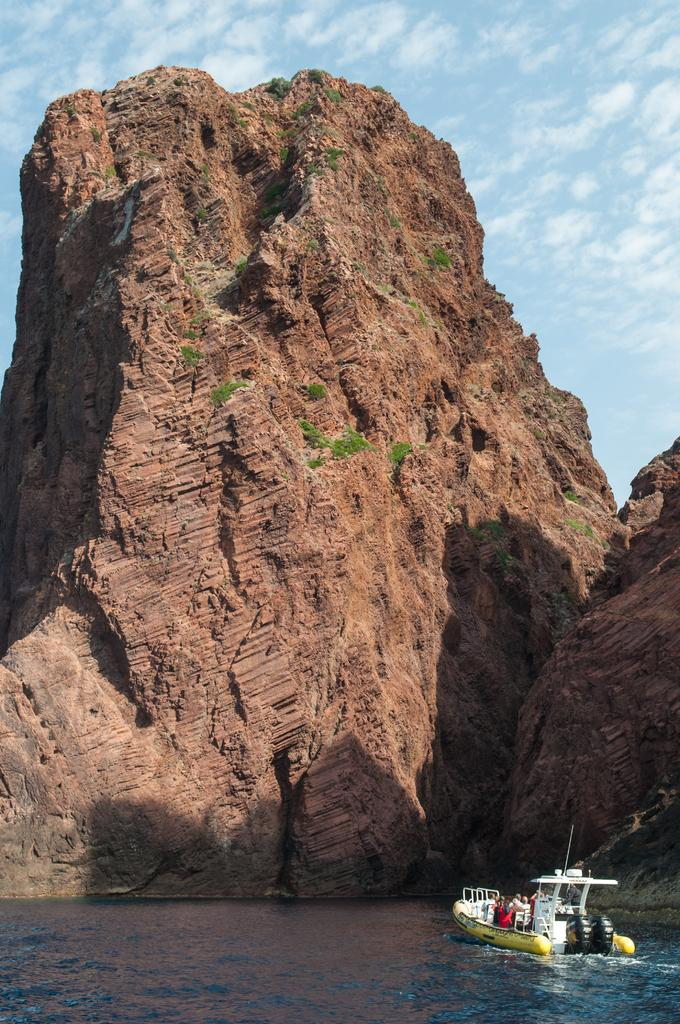What is located at the bottom of the image? There is a boat on the water at the bottom of the image. Who or what is inside the boat? There are people in the boat. What can be seen in the background of the image? There are hills in the background of the image. What is visible at the top of the image? The sky is visible at the top of the image. What is present in the sky? There are clouds in the sky. How many wrens can be seen flying in the image? There are no wrens present in the image. What is the fifth element in the image? The image only contains five elements mentioned in the facts: a boat, water, people, hills, and the sky. There is no fifth element. 